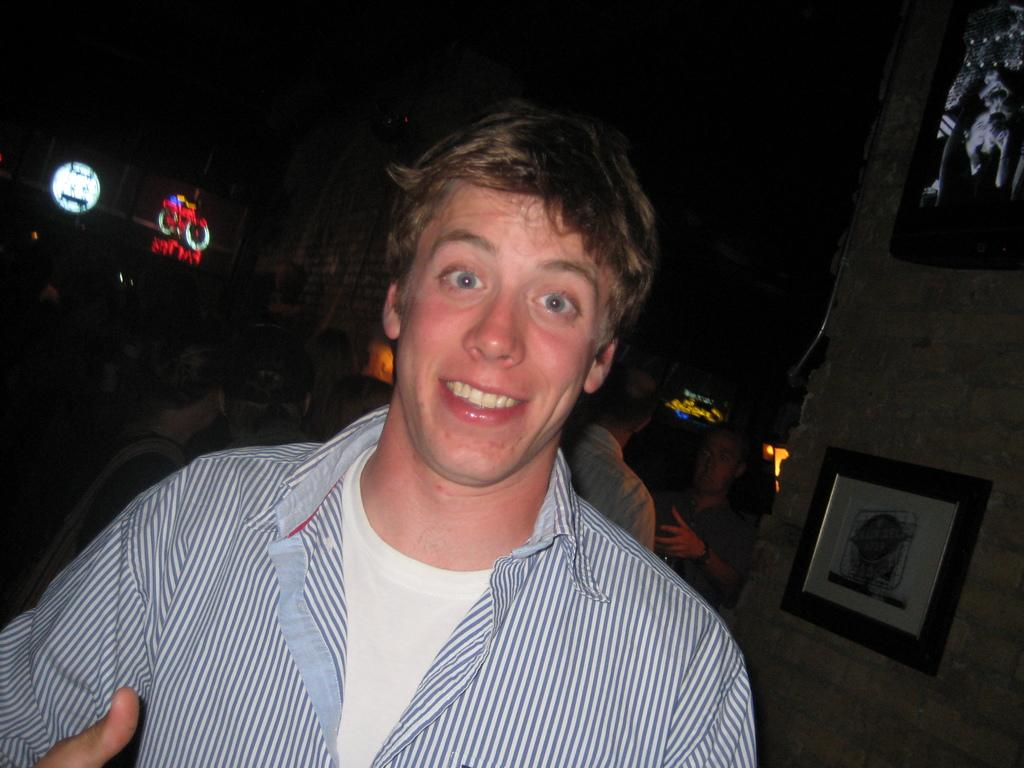Who or what is present in the image? There are people in the image. What can be seen on the walls in the image? There are photo frames on the walls. Can you describe the background of the image? The background of the image is blurred. How many rabbits can be seen playing with the chicken in the image? There are no rabbits or chickens present in the image. What message of peace is conveyed by the people in the image? The image does not convey a specific message of peace; it only shows people and photo frames on the walls. 